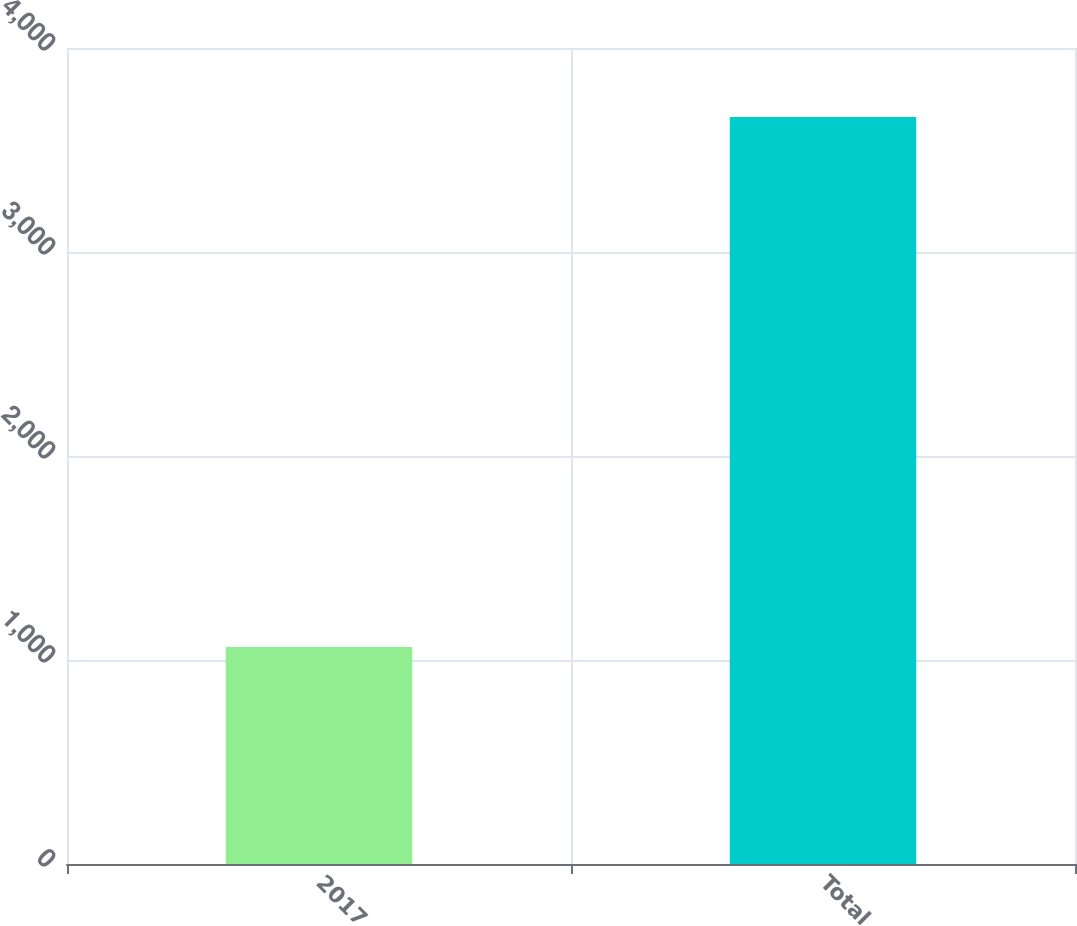Convert chart. <chart><loc_0><loc_0><loc_500><loc_500><bar_chart><fcel>2017<fcel>Total<nl><fcel>1064<fcel>3662<nl></chart> 